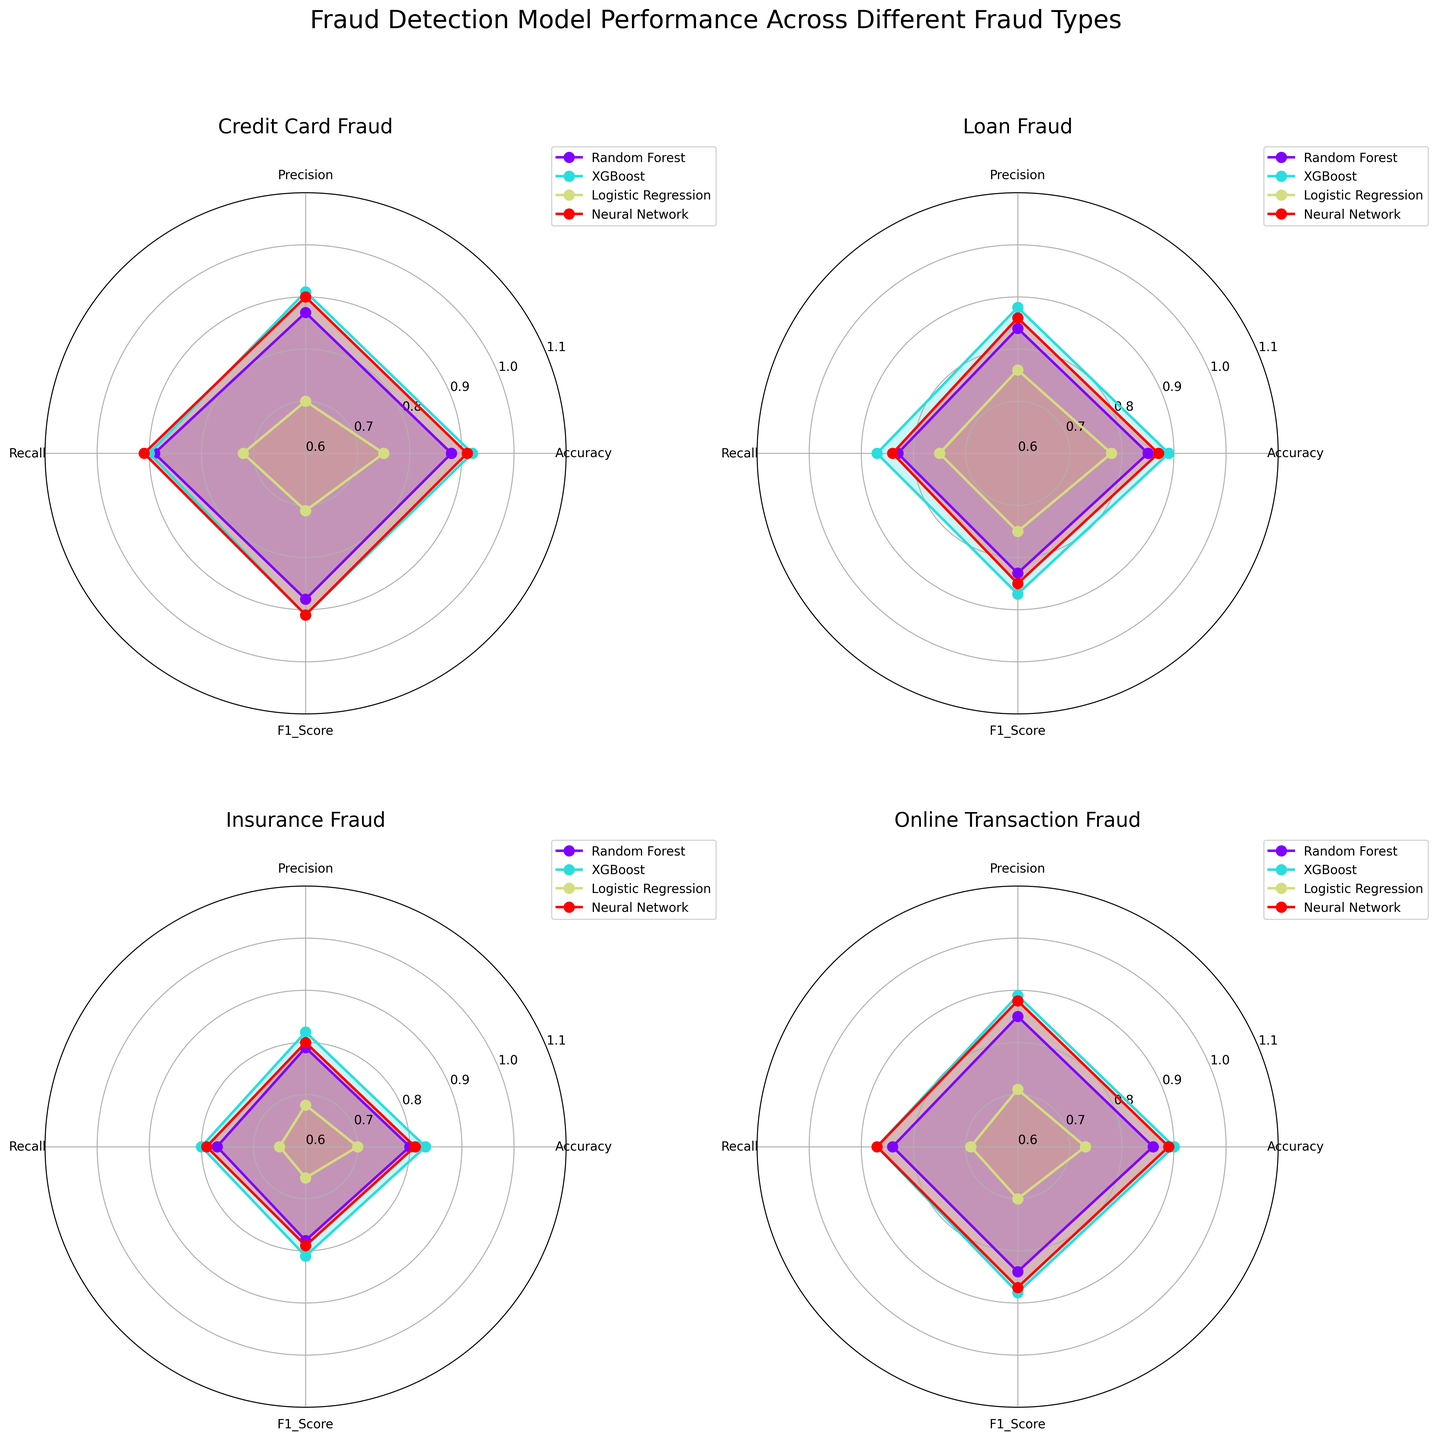What are the four fraud types examined in the figure? The figure analyzes four different fraud types. Each subplot's title indicates the fraud type being analyzed. The titles are “Credit Card Fraud,” “Loan Fraud,” “Insurance Fraud,” and “Online Transaction Fraud.”
Answer: Credit Card Fraud, Loan Fraud, Insurance Fraud, Online Transaction Fraud Which model performs the best in detecting Credit Card Fraud based on accuracy? To determine which model has the best accuracy for Credit Card Fraud, examine the subplot titled "Credit Card Fraud." The model with the highest value on the accuracy axis (closest to 1) is XGBoost.
Answer: XGBoost Between Random Forest and Neural Network, which model has a higher precision for Loan Fraud detection? Compare the precision values of the Random Forest and Neural Network models in the Loan Fraud subplot. The plot shows that Neural Network has a precision value higher than Random Forest.
Answer: Neural Network Which metric shows the greatest variability across all models for Insurance Fraud? Look at the Insurance Fraud subplot and assess which metric (Accuracy, Precision, Recall, F1_Score) has the widest spread of values across the models. Precision shows the greatest difference between the highest and lowest values.
Answer: Precision How does the performance of Logistic Regression compare for detecting Insurance Fraud versus Online Transaction Fraud based on F1 Score? Check the F1 Score for Logistic Regression in both the Insurance Fraud and Online Transaction Fraud subplots. For Insurance Fraud, the F1 Score is 0.66, while for Online Transaction Fraud, it is 0.70.
Answer: Online Transaction Fraud is better Which model has an overall balanced performance across all four metrics for Online Transaction Fraud? In the Online Transaction Fraud subplot, evaluate which model is closest to achieving similar value levels across Accuracy, Precision, Recall, and F1 Score. Neural Network has balanced values for all four metrics.
Answer: Neural Network How does the precision of XGBoost for detecting Online Transaction Fraud compare to its precision for detecting Loan Fraud? Look at the precision values for XGBoost in both the Online Transaction Fraud and Loan Fraud subplots. The precision for Online Transaction Fraud is 0.89, while for Loan Fraud, it is 0.88.
Answer: Online Transaction Fraud is higher What can be inferred about the overall effectiveness of Logistic Regression model in fraud detection across all types of fraud analyzed? Examine the subplots corresponding to each fraud type and observe the values for Logistic Regression across all metrics. Logistic Regression generally shows lower values compared to the other models, indicating it is less effective across different types of fraud.
Answer: Less effective across all types For which fraud type is the F1 Score of Neural Network consistently higher than 0.85? Scan through the Neural Network F1 Score values for all subplots. For Credit Card Fraud (0.91), Loan Fraud (0.85), and Online Transaction Fraud (0.87), the F1 Score is consistently higher than 0.85. However, for Insurance Fraud, it is lower at 0.79.
Answer: Credit Card Fraud, Loan Fraud, Online Transaction Fraud Which model shows the smallest drop in accuracy between detecting Credit Card Fraud and Insurance Fraud? Compare the accuracy values of each model for Credit Card Fraud and Insurance Fraud. Neural Network has an accuracy of 0.91 for Credit Card Fraud and 0.81 for Insurance Fraud, the smallest drop among the models listed.
Answer: Neural Network 